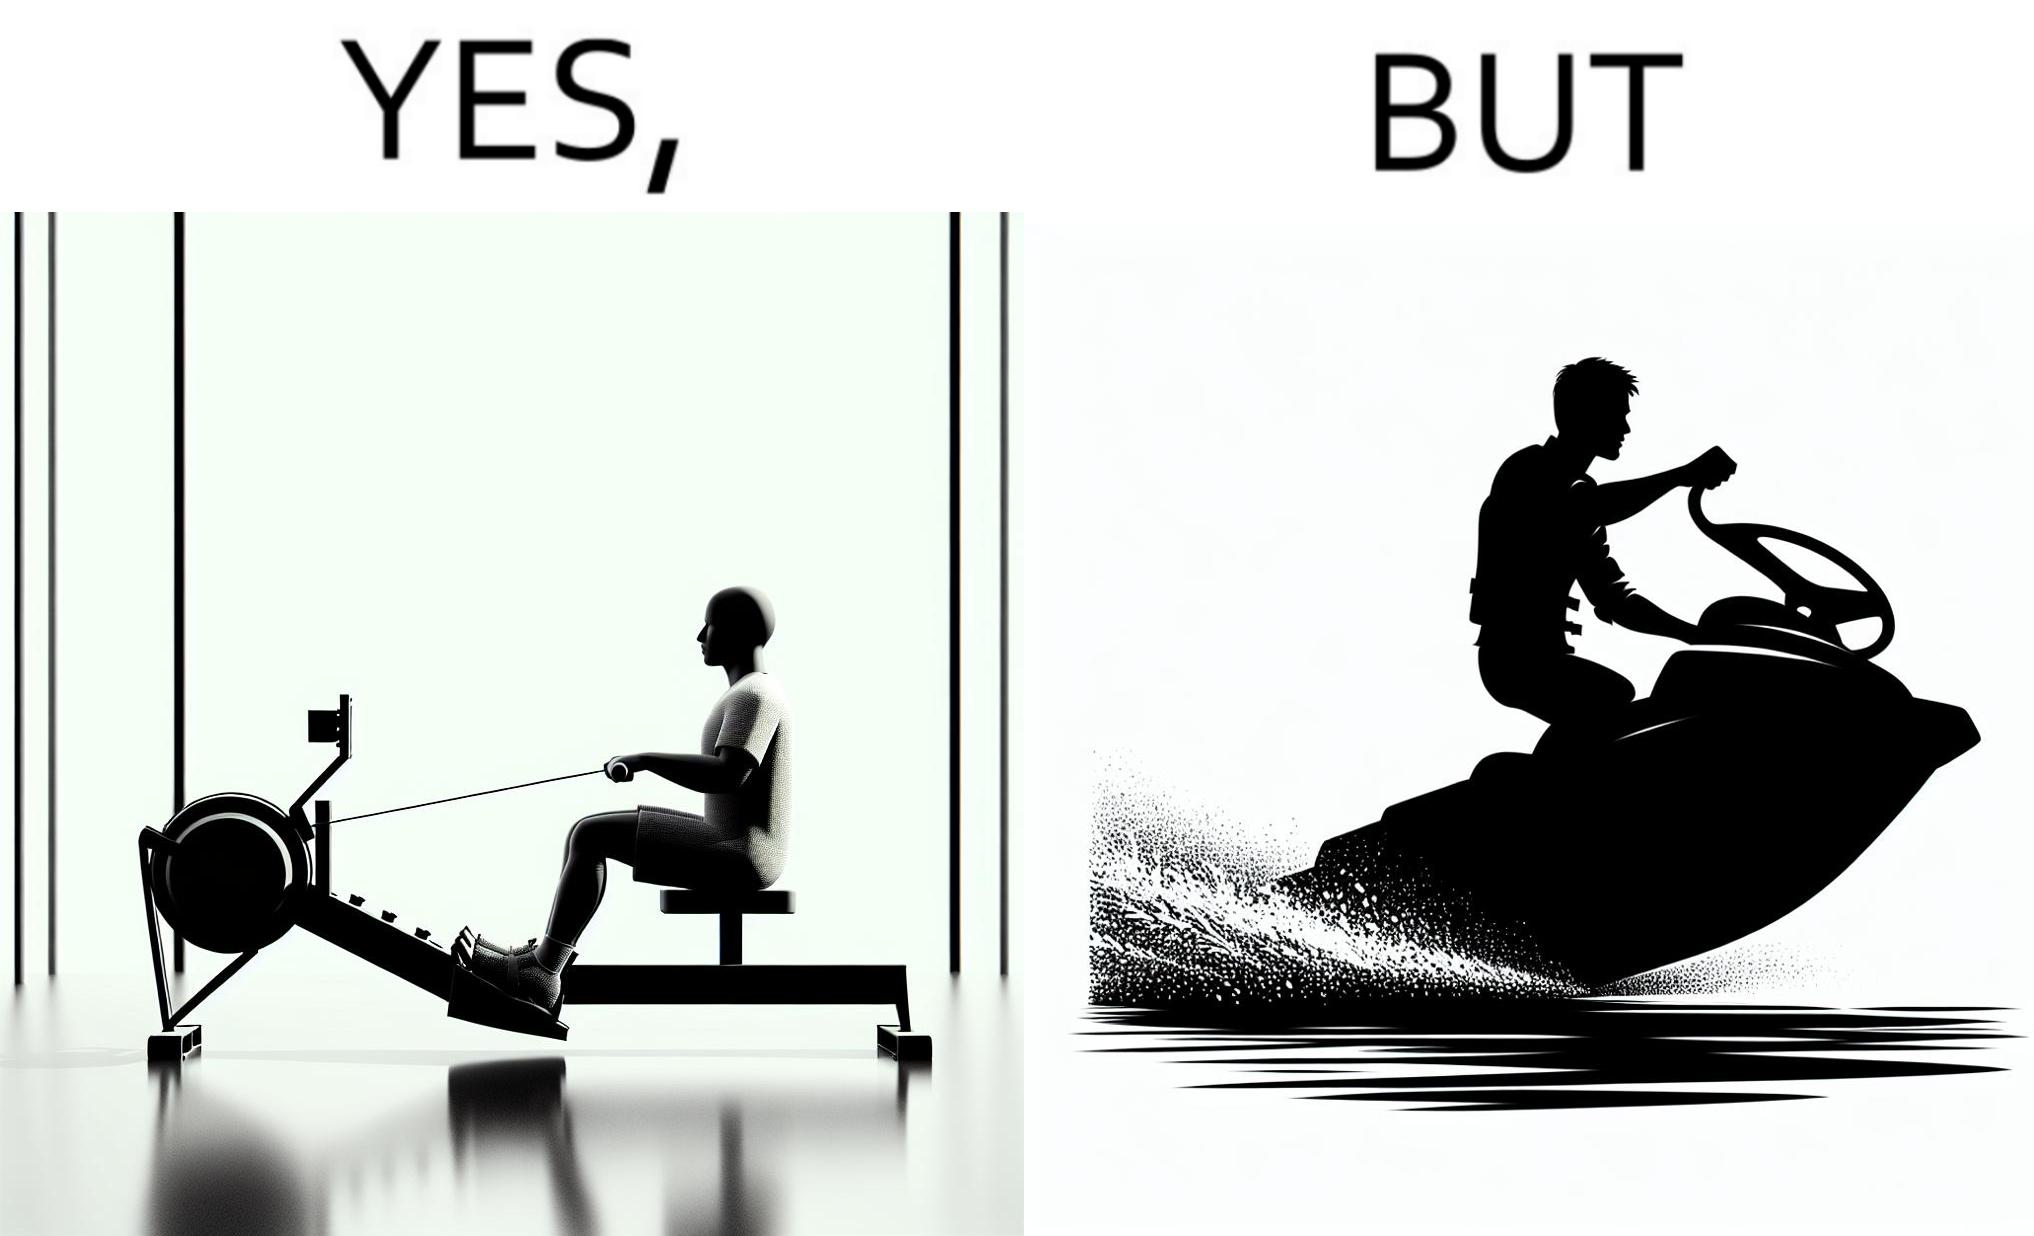Explain why this image is satirical. The image is ironic, because people often use rowing machine at the gym don't prefer rowing when it comes to boats 